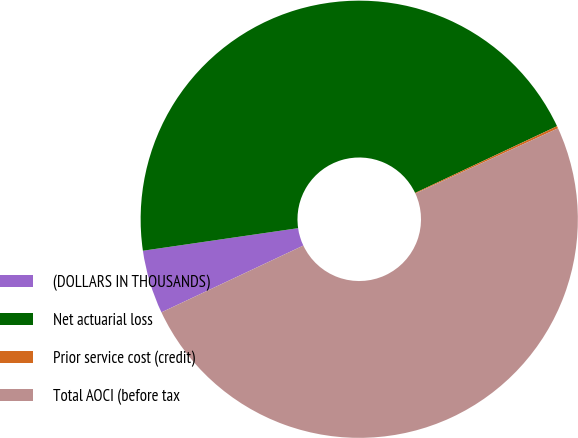Convert chart. <chart><loc_0><loc_0><loc_500><loc_500><pie_chart><fcel>(DOLLARS IN THOUSANDS)<fcel>Net actuarial loss<fcel>Prior service cost (credit)<fcel>Total AOCI (before tax<nl><fcel>4.7%<fcel>45.3%<fcel>0.17%<fcel>49.83%<nl></chart> 